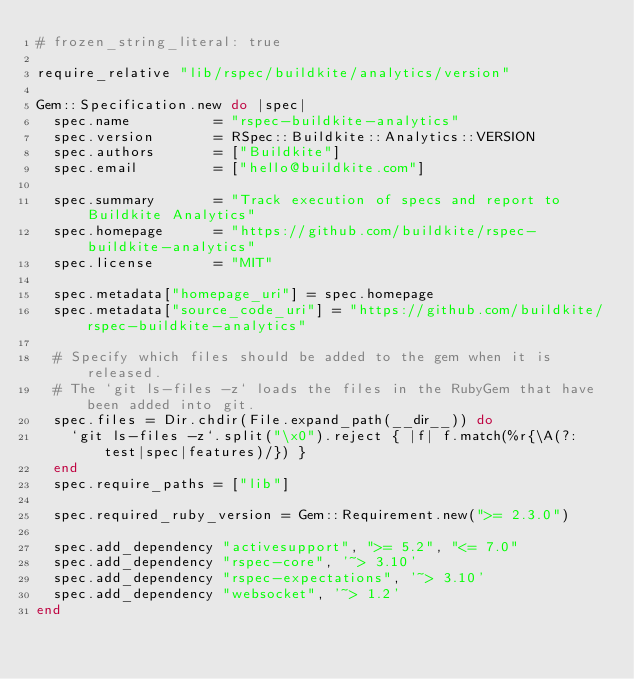Convert code to text. <code><loc_0><loc_0><loc_500><loc_500><_Ruby_># frozen_string_literal: true

require_relative "lib/rspec/buildkite/analytics/version"

Gem::Specification.new do |spec|
  spec.name          = "rspec-buildkite-analytics"
  spec.version       = RSpec::Buildkite::Analytics::VERSION
  spec.authors       = ["Buildkite"]
  spec.email         = ["hello@buildkite.com"]

  spec.summary       = "Track execution of specs and report to Buildkite Analytics"
  spec.homepage      = "https://github.com/buildkite/rspec-buildkite-analytics"
  spec.license       = "MIT"

  spec.metadata["homepage_uri"] = spec.homepage
  spec.metadata["source_code_uri"] = "https://github.com/buildkite/rspec-buildkite-analytics"

  # Specify which files should be added to the gem when it is released.
  # The `git ls-files -z` loads the files in the RubyGem that have been added into git.
  spec.files = Dir.chdir(File.expand_path(__dir__)) do
    `git ls-files -z`.split("\x0").reject { |f| f.match(%r{\A(?:test|spec|features)/}) }
  end
  spec.require_paths = ["lib"]

  spec.required_ruby_version = Gem::Requirement.new(">= 2.3.0")

  spec.add_dependency "activesupport", ">= 5.2", "<= 7.0"
  spec.add_dependency "rspec-core", '~> 3.10'
  spec.add_dependency "rspec-expectations", '~> 3.10'
  spec.add_dependency "websocket", '~> 1.2'
end
</code> 